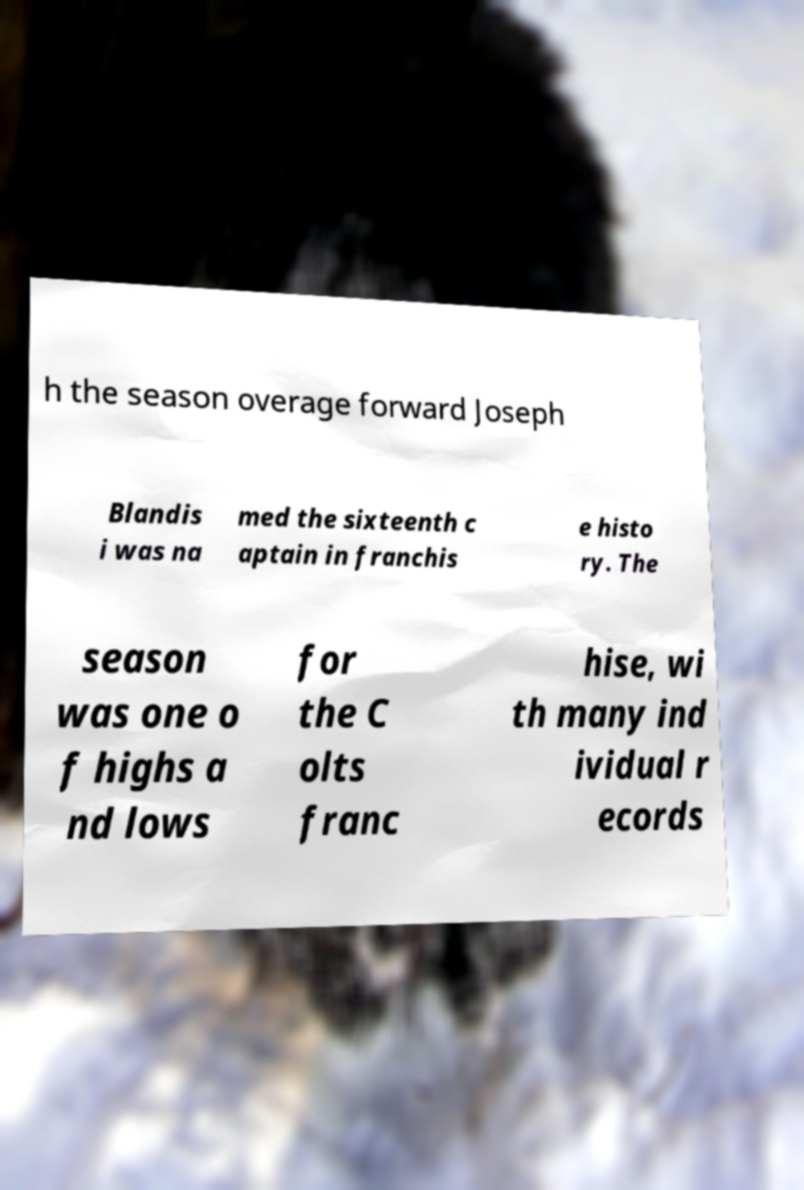Please identify and transcribe the text found in this image. h the season overage forward Joseph Blandis i was na med the sixteenth c aptain in franchis e histo ry. The season was one o f highs a nd lows for the C olts franc hise, wi th many ind ividual r ecords 